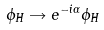<formula> <loc_0><loc_0><loc_500><loc_500>\phi _ { H } \rightarrow e ^ { - i \alpha } \phi _ { H }</formula> 